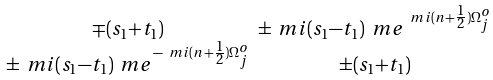Convert formula to latex. <formula><loc_0><loc_0><loc_500><loc_500>\begin{smallmatrix} \mp ( s _ { 1 } + t _ { 1 } ) & \pm \ m i ( s _ { 1 } - t _ { 1 } ) \ m e ^ { \ m i ( n + \frac { 1 } { 2 } ) \Omega _ { j } ^ { o } } \\ \pm \ m i ( s _ { 1 } - t _ { 1 } ) \ m e ^ { - \ m i ( n + \frac { 1 } { 2 } ) \Omega _ { j } ^ { o } } & \pm ( s _ { 1 } + t _ { 1 } ) \end{smallmatrix}</formula> 